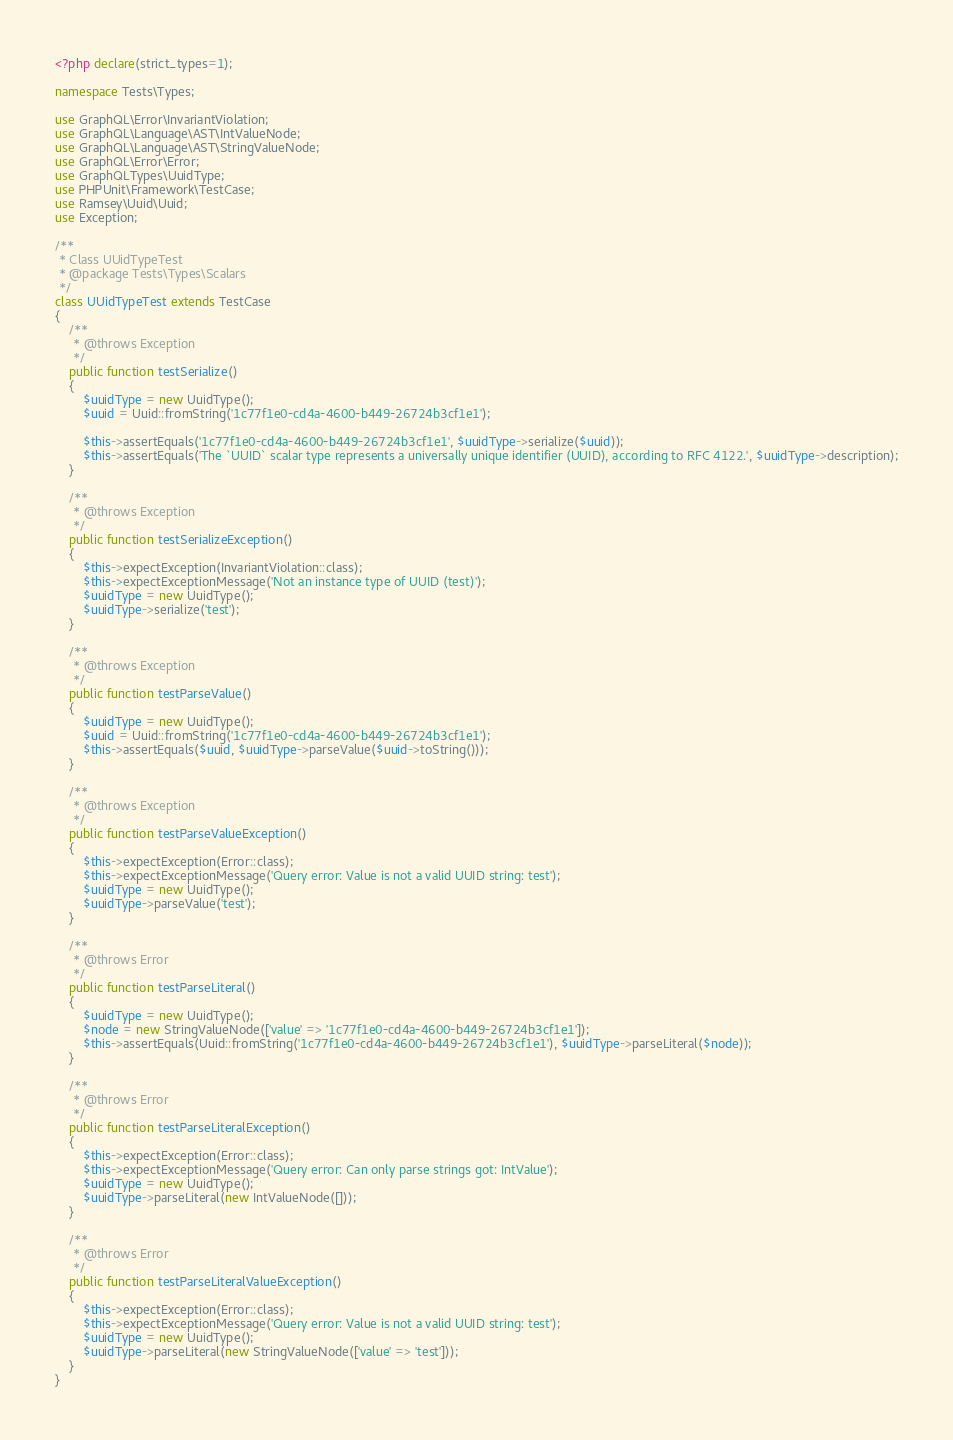Convert code to text. <code><loc_0><loc_0><loc_500><loc_500><_PHP_><?php declare(strict_types=1);

namespace Tests\Types;

use GraphQL\Error\InvariantViolation;
use GraphQL\Language\AST\IntValueNode;
use GraphQL\Language\AST\StringValueNode;
use GraphQL\Error\Error;
use GraphQLTypes\UuidType;
use PHPUnit\Framework\TestCase;
use Ramsey\Uuid\Uuid;
use Exception;

/**
 * Class UUidTypeTest
 * @package Tests\Types\Scalars
 */
class UUidTypeTest extends TestCase
{
    /**
     * @throws Exception
     */
    public function testSerialize()
    {
        $uuidType = new UuidType();
        $uuid = Uuid::fromString('1c77f1e0-cd4a-4600-b449-26724b3cf1e1');

        $this->assertEquals('1c77f1e0-cd4a-4600-b449-26724b3cf1e1', $uuidType->serialize($uuid));
        $this->assertEquals('The `UUID` scalar type represents a universally unique identifier (UUID), according to RFC 4122.', $uuidType->description);
    }

    /**
     * @throws Exception
     */
    public function testSerializeException()
    {
        $this->expectException(InvariantViolation::class);
        $this->expectExceptionMessage('Not an instance type of UUID (test)');
        $uuidType = new UuidType();
        $uuidType->serialize('test');
    }

    /**
     * @throws Exception
     */
    public function testParseValue()
    {
        $uuidType = new UuidType();
        $uuid = Uuid::fromString('1c77f1e0-cd4a-4600-b449-26724b3cf1e1');
        $this->assertEquals($uuid, $uuidType->parseValue($uuid->toString()));
    }

    /**
     * @throws Exception
     */
    public function testParseValueException()
    {
        $this->expectException(Error::class);
        $this->expectExceptionMessage('Query error: Value is not a valid UUID string: test');
        $uuidType = new UuidType();
        $uuidType->parseValue('test');
    }

    /**
     * @throws Error
     */
    public function testParseLiteral()
    {
        $uuidType = new UuidType();
        $node = new StringValueNode(['value' => '1c77f1e0-cd4a-4600-b449-26724b3cf1e1']);
        $this->assertEquals(Uuid::fromString('1c77f1e0-cd4a-4600-b449-26724b3cf1e1'), $uuidType->parseLiteral($node));
    }

    /**
     * @throws Error
     */
    public function testParseLiteralException()
    {
        $this->expectException(Error::class);
        $this->expectExceptionMessage('Query error: Can only parse strings got: IntValue');
        $uuidType = new UuidType();
        $uuidType->parseLiteral(new IntValueNode([]));
    }

    /**
     * @throws Error
     */
    public function testParseLiteralValueException()
    {
        $this->expectException(Error::class);
        $this->expectExceptionMessage('Query error: Value is not a valid UUID string: test');
        $uuidType = new UuidType();
        $uuidType->parseLiteral(new StringValueNode(['value' => 'test']));
    }
}
</code> 